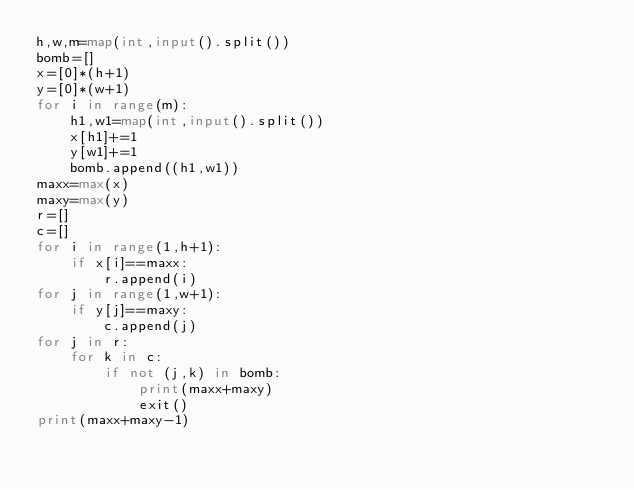<code> <loc_0><loc_0><loc_500><loc_500><_Python_>h,w,m=map(int,input().split())
bomb=[]
x=[0]*(h+1)
y=[0]*(w+1)
for i in range(m):
    h1,w1=map(int,input().split())
    x[h1]+=1
    y[w1]+=1
    bomb.append((h1,w1))
maxx=max(x)
maxy=max(y)
r=[]
c=[]
for i in range(1,h+1):
    if x[i]==maxx:
        r.append(i)
for j in range(1,w+1):
    if y[j]==maxy:
        c.append(j)
for j in r:
    for k in c:
        if not (j,k) in bomb:
            print(maxx+maxy)
            exit()
print(maxx+maxy-1)</code> 